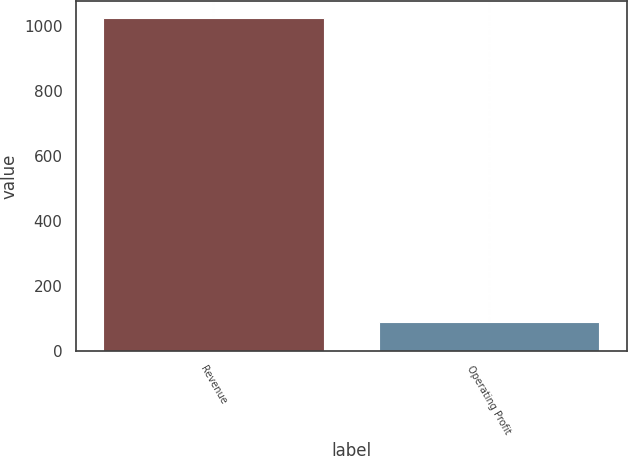Convert chart. <chart><loc_0><loc_0><loc_500><loc_500><bar_chart><fcel>Revenue<fcel>Operating Profit<nl><fcel>1026.7<fcel>89.7<nl></chart> 